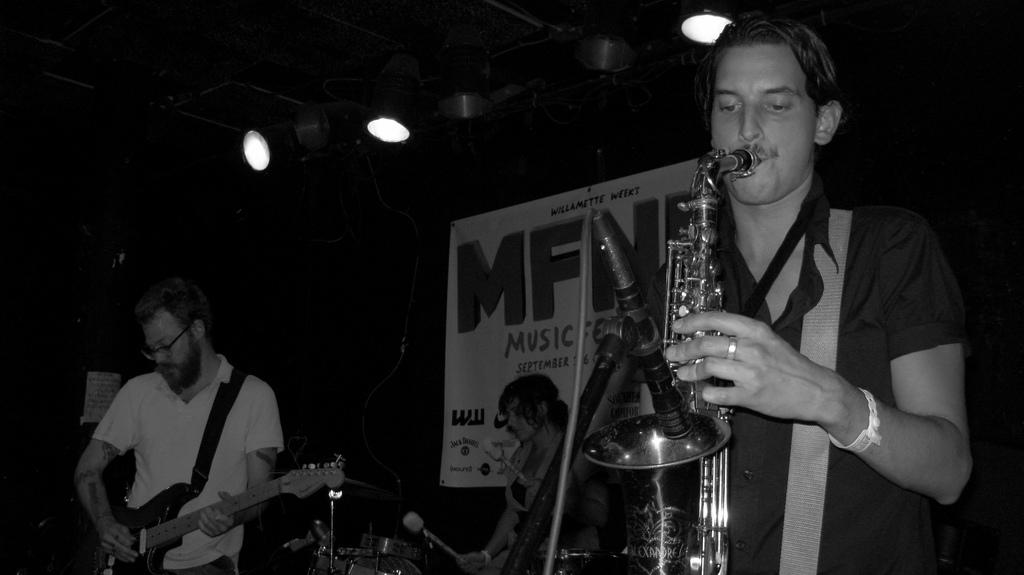How many people are in the image? There are three people in the image. What are the people doing in the image? The people are playing musical instruments. What can be seen on the roof in the image? There are lights on the roof. What is hanging on the wall in the image? There is a banner on the wall. What type of nerve is visible in the image? There is no nerve visible in the image. What kind of work is being done on the roof in the image? There is no work being done on the roof in the image; there are only lights visible. 